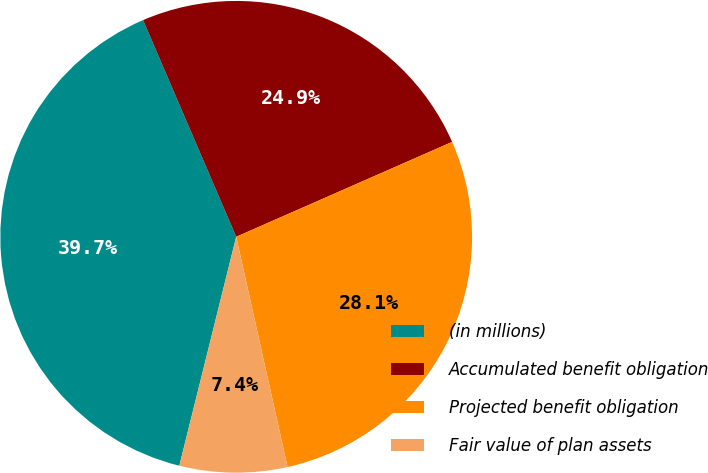Convert chart. <chart><loc_0><loc_0><loc_500><loc_500><pie_chart><fcel>(in millions)<fcel>Accumulated benefit obligation<fcel>Projected benefit obligation<fcel>Fair value of plan assets<nl><fcel>39.67%<fcel>24.87%<fcel>28.1%<fcel>7.37%<nl></chart> 